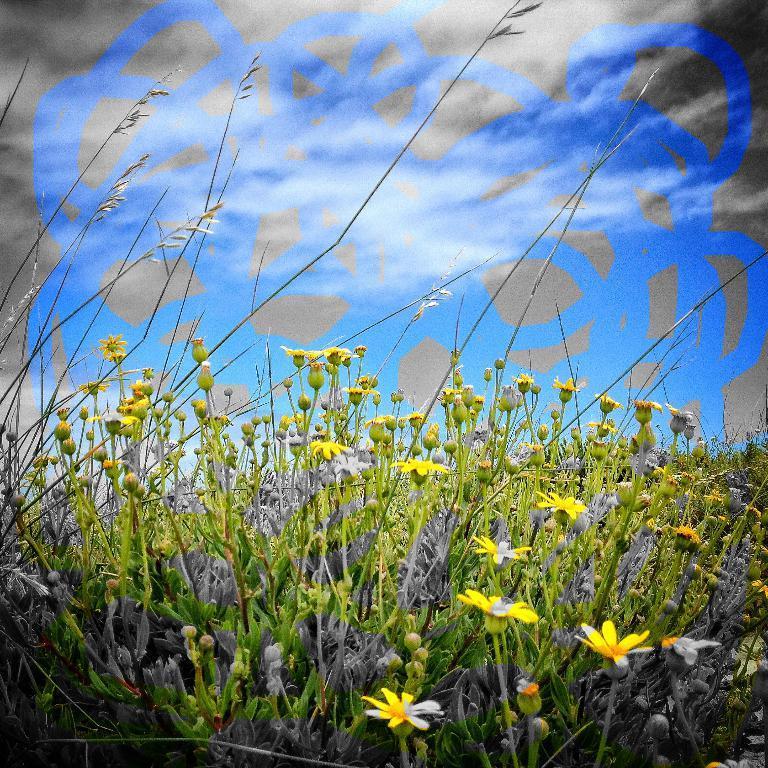How would you summarize this image in a sentence or two? In this image there are plants for that plants there are flowers and buds, in the background there is a poster, on that poster there is some painting. 